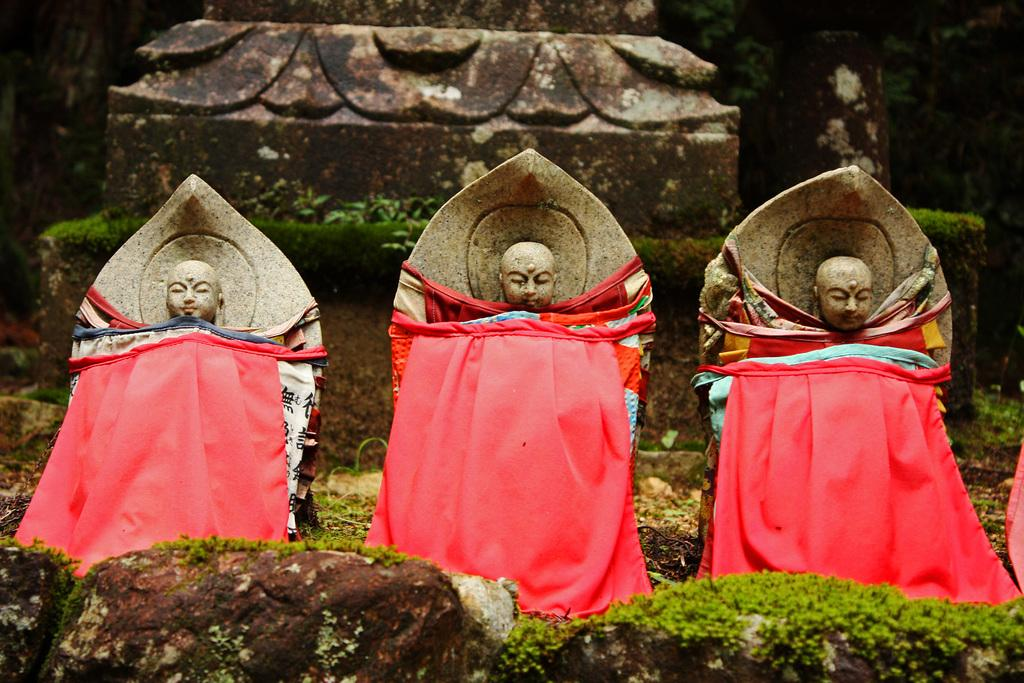What is the main subject in the center of the image? There are sculptures in the center of the image. What else can be seen in the image besides the sculptures? There are clothes and rocks visible in the image. What type of vegetation is present in the image? There is a hedge in the image. How many hands are holding the sculptures in the image? There is no indication of hands holding the sculptures in the image. 